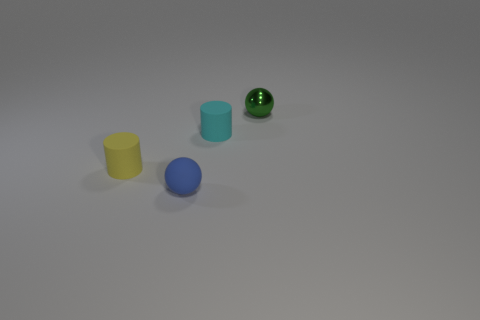If we were to organize these objects by size, from smallest to largest, how would they be ordered? The order from smallest to largest based on their visible size would be: green speckled sphere, yellow cylinder, blue sphere, and finally the cyan cube as the largest. 